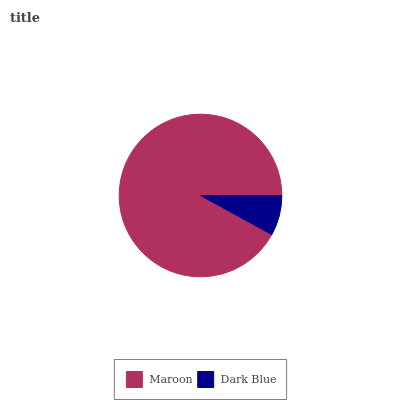Is Dark Blue the minimum?
Answer yes or no. Yes. Is Maroon the maximum?
Answer yes or no. Yes. Is Dark Blue the maximum?
Answer yes or no. No. Is Maroon greater than Dark Blue?
Answer yes or no. Yes. Is Dark Blue less than Maroon?
Answer yes or no. Yes. Is Dark Blue greater than Maroon?
Answer yes or no. No. Is Maroon less than Dark Blue?
Answer yes or no. No. Is Maroon the high median?
Answer yes or no. Yes. Is Dark Blue the low median?
Answer yes or no. Yes. Is Dark Blue the high median?
Answer yes or no. No. Is Maroon the low median?
Answer yes or no. No. 